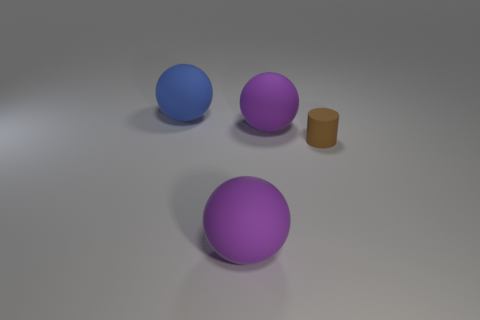Subtract all blue spheres. How many spheres are left? 2 Subtract all purple spheres. How many spheres are left? 1 Add 1 small brown objects. How many objects exist? 5 Subtract 1 spheres. How many spheres are left? 2 Subtract all balls. How many objects are left? 1 Subtract all blue balls. Subtract all purple blocks. How many balls are left? 2 Subtract all green cylinders. How many blue spheres are left? 1 Subtract all gray rubber things. Subtract all large spheres. How many objects are left? 1 Add 2 blue matte objects. How many blue matte objects are left? 3 Add 1 brown rubber things. How many brown rubber things exist? 2 